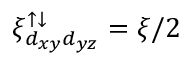Convert formula to latex. <formula><loc_0><loc_0><loc_500><loc_500>\xi _ { d _ { x y } d _ { y z } } ^ { \uparrow \downarrow } = \xi / 2</formula> 